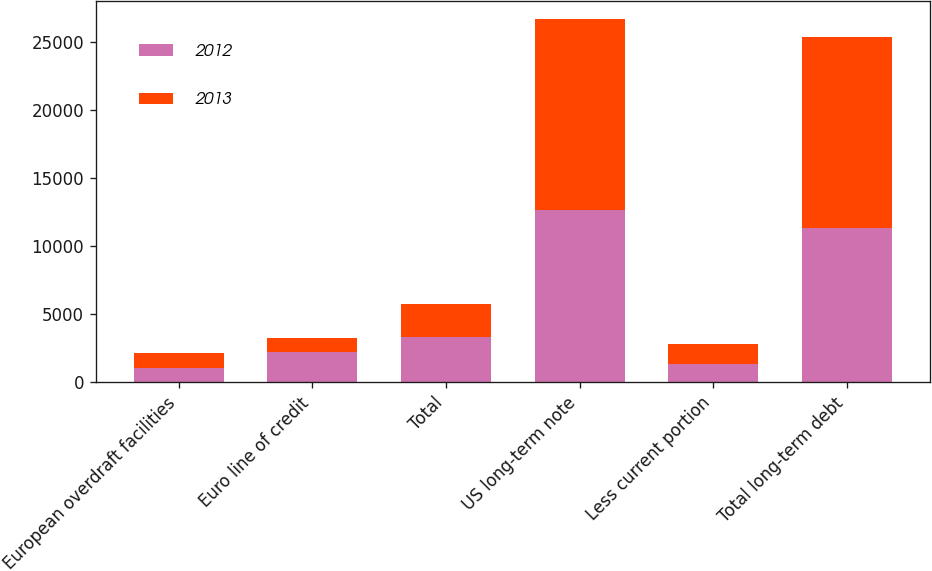Convert chart to OTSL. <chart><loc_0><loc_0><loc_500><loc_500><stacked_bar_chart><ecel><fcel>European overdraft facilities<fcel>Euro line of credit<fcel>Total<fcel>US long-term note<fcel>Less current portion<fcel>Total long-term debt<nl><fcel>2012<fcel>1038<fcel>2258<fcel>3296<fcel>12666<fcel>1333<fcel>11333<nl><fcel>2013<fcel>1135<fcel>956<fcel>2442<fcel>14000<fcel>1505<fcel>14014<nl></chart> 